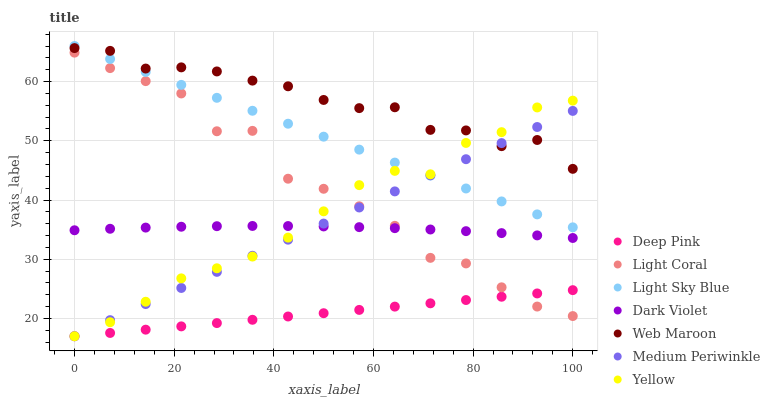Does Deep Pink have the minimum area under the curve?
Answer yes or no. Yes. Does Web Maroon have the maximum area under the curve?
Answer yes or no. Yes. Does Medium Periwinkle have the minimum area under the curve?
Answer yes or no. No. Does Medium Periwinkle have the maximum area under the curve?
Answer yes or no. No. Is Deep Pink the smoothest?
Answer yes or no. Yes. Is Light Coral the roughest?
Answer yes or no. Yes. Is Web Maroon the smoothest?
Answer yes or no. No. Is Web Maroon the roughest?
Answer yes or no. No. Does Deep Pink have the lowest value?
Answer yes or no. Yes. Does Web Maroon have the lowest value?
Answer yes or no. No. Does Light Sky Blue have the highest value?
Answer yes or no. Yes. Does Web Maroon have the highest value?
Answer yes or no. No. Is Deep Pink less than Web Maroon?
Answer yes or no. Yes. Is Dark Violet greater than Deep Pink?
Answer yes or no. Yes. Does Medium Periwinkle intersect Deep Pink?
Answer yes or no. Yes. Is Medium Periwinkle less than Deep Pink?
Answer yes or no. No. Is Medium Periwinkle greater than Deep Pink?
Answer yes or no. No. Does Deep Pink intersect Web Maroon?
Answer yes or no. No. 